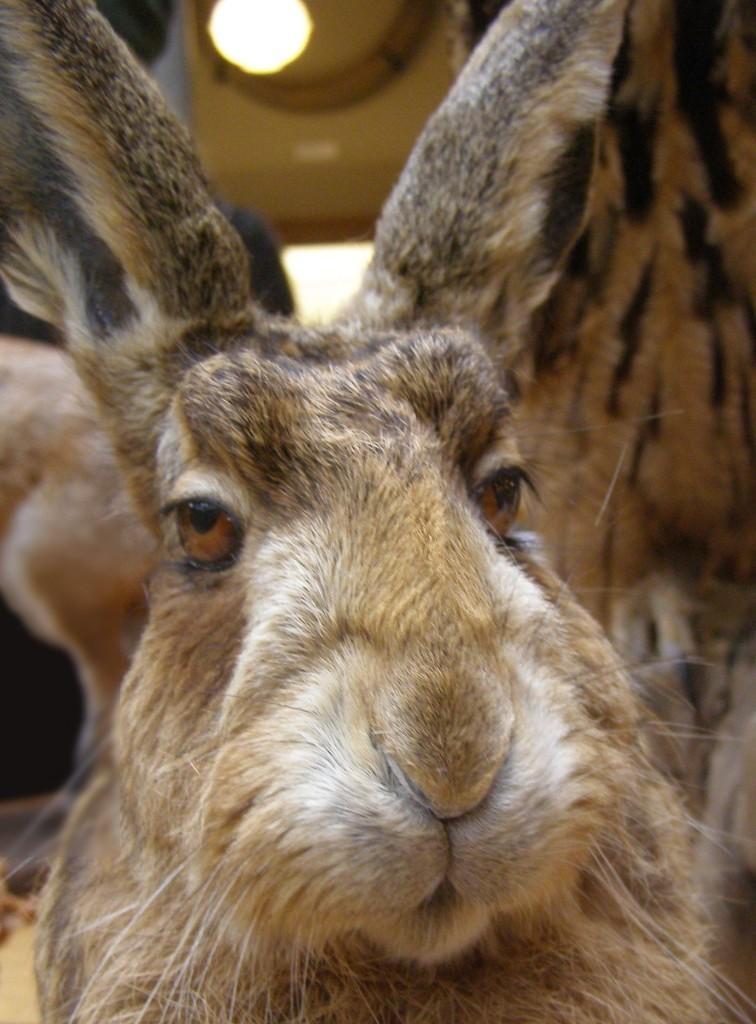Describe this image in one or two sentences. In this picture, we see a rabbit having two ears, eyes, nose and mouth. It even has whiskers. Behind that, we see a bulb. 